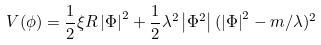<formula> <loc_0><loc_0><loc_500><loc_500>V ( \phi ) = \frac { 1 } { 2 } \xi R \left | \Phi \right | ^ { 2 } + \frac { 1 } { 2 } \lambda ^ { 2 } \left | \Phi ^ { 2 } \right | ( \left | \Phi \right | ^ { 2 } - m / \lambda ) ^ { 2 }</formula> 